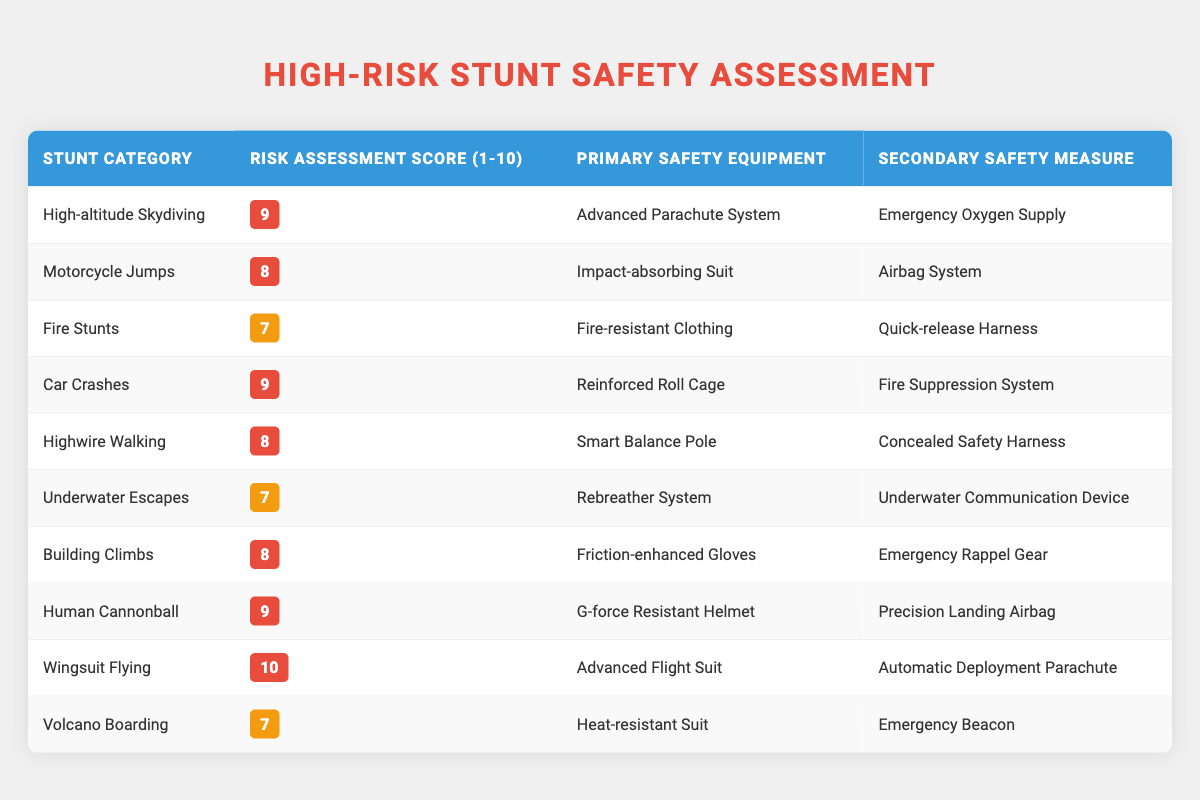What stunt category has the highest risk assessment score? The highest score in the table is 10, which corresponds to the stunt category "Wingsuit Flying."
Answer: Wingsuit Flying How many stunt categories have a risk assessment score of 8? The table shows three stunt categories with a score of 8: "Motorcycle Jumps," "Highwire Walking," and "Building Climbs."
Answer: 3 Is the primary safety equipment for "Car Crashes" a reinforced roll cage? According to the table, the primary safety equipment for "Car Crashes" is indeed a "Reinforced Roll Cage."
Answer: Yes What is the average risk assessment score for all stunt categories? First, add all the risk scores: 9 + 8 + 7 + 9 + 8 + 7 + 8 + 9 + 10 + 7 = 82. There are 10 stunt categories, so the average is 82/10 = 8.2.
Answer: 8.2 Which stunt categories have a risk assessment score of 7? The stunt categories with a score of 7 are "Fire Stunts," "Underwater Escapes," and "Volcano Boarding."
Answer: Fire Stunts, Underwater Escapes, Volcano Boarding Which safety equipment is listed as the secondary safety measure for "High-altitude Skydiving"? The secondary safety measure for "High-altitude Skydiving" is "Emergency Oxygen Supply" as stated in the table.
Answer: Emergency Oxygen Supply What is the difference in risk assessment scores between "Wingsuit Flying" and "Car Crashes"? "Wingsuit Flying" has a score of 10 and "Car Crashes" has a score of 9. The difference is 10 - 9 = 1.
Answer: 1 Does any stunt category have a risk assessment score lower than 7? Scanning the table, all stunt categories have a score of 7 or higher, confirming there are none below 7.
Answer: No 